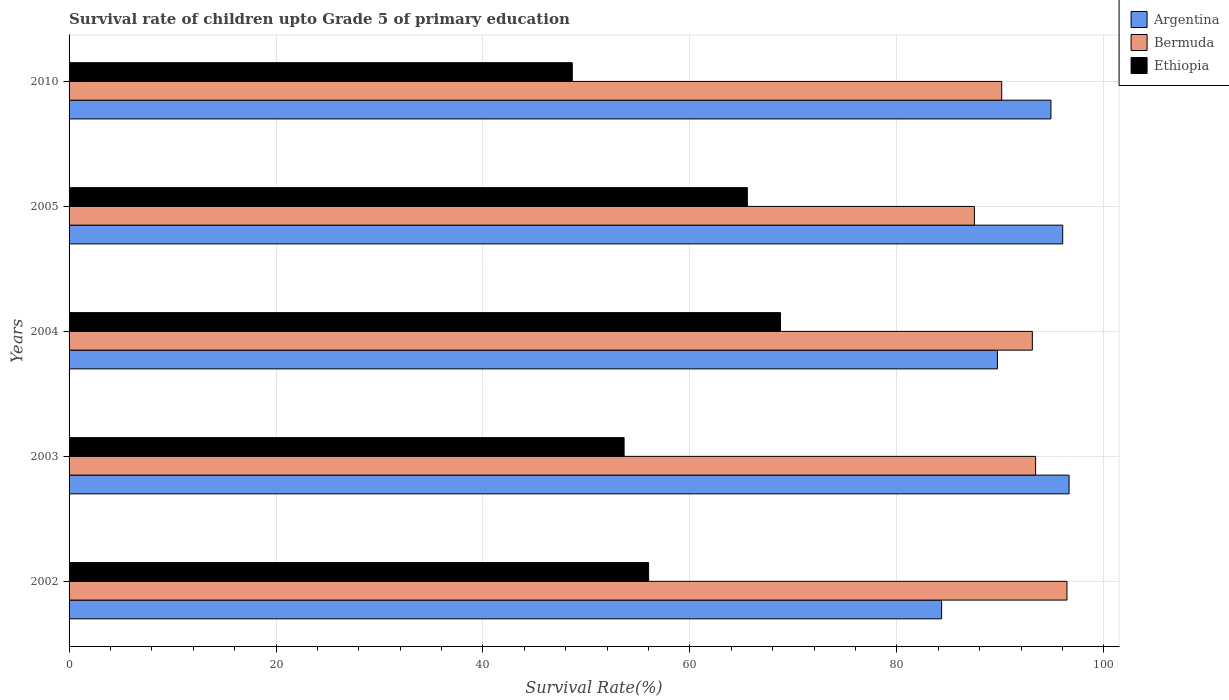How many different coloured bars are there?
Keep it short and to the point. 3. How many groups of bars are there?
Keep it short and to the point. 5. Are the number of bars on each tick of the Y-axis equal?
Your answer should be compact. Yes. How many bars are there on the 5th tick from the top?
Make the answer very short. 3. What is the survival rate of children in Argentina in 2004?
Make the answer very short. 89.72. Across all years, what is the maximum survival rate of children in Bermuda?
Offer a very short reply. 96.44. Across all years, what is the minimum survival rate of children in Ethiopia?
Your answer should be very brief. 48.63. In which year was the survival rate of children in Bermuda maximum?
Your response must be concise. 2002. What is the total survival rate of children in Ethiopia in the graph?
Your answer should be very brief. 292.58. What is the difference between the survival rate of children in Argentina in 2005 and that in 2010?
Provide a succinct answer. 1.14. What is the difference between the survival rate of children in Ethiopia in 2003 and the survival rate of children in Bermuda in 2002?
Your response must be concise. -42.8. What is the average survival rate of children in Ethiopia per year?
Your response must be concise. 58.52. In the year 2005, what is the difference between the survival rate of children in Ethiopia and survival rate of children in Bermuda?
Your response must be concise. -21.94. What is the ratio of the survival rate of children in Bermuda in 2003 to that in 2004?
Ensure brevity in your answer.  1. Is the survival rate of children in Ethiopia in 2002 less than that in 2004?
Make the answer very short. Yes. What is the difference between the highest and the second highest survival rate of children in Bermuda?
Provide a succinct answer. 3.03. What is the difference between the highest and the lowest survival rate of children in Bermuda?
Your answer should be very brief. 8.95. What does the 1st bar from the top in 2004 represents?
Your answer should be compact. Ethiopia. What does the 2nd bar from the bottom in 2010 represents?
Give a very brief answer. Bermuda. Is it the case that in every year, the sum of the survival rate of children in Argentina and survival rate of children in Bermuda is greater than the survival rate of children in Ethiopia?
Your answer should be compact. Yes. How many bars are there?
Your answer should be compact. 15. Are all the bars in the graph horizontal?
Keep it short and to the point. Yes. How many years are there in the graph?
Give a very brief answer. 5. Does the graph contain grids?
Offer a terse response. Yes. How are the legend labels stacked?
Provide a succinct answer. Vertical. What is the title of the graph?
Provide a short and direct response. Survival rate of children upto Grade 5 of primary education. Does "Lao PDR" appear as one of the legend labels in the graph?
Provide a succinct answer. No. What is the label or title of the X-axis?
Keep it short and to the point. Survival Rate(%). What is the Survival Rate(%) in Argentina in 2002?
Your response must be concise. 84.33. What is the Survival Rate(%) of Bermuda in 2002?
Provide a succinct answer. 96.44. What is the Survival Rate(%) of Ethiopia in 2002?
Provide a short and direct response. 56.01. What is the Survival Rate(%) in Argentina in 2003?
Your response must be concise. 96.64. What is the Survival Rate(%) in Bermuda in 2003?
Your response must be concise. 93.41. What is the Survival Rate(%) of Ethiopia in 2003?
Give a very brief answer. 53.64. What is the Survival Rate(%) in Argentina in 2004?
Offer a very short reply. 89.72. What is the Survival Rate(%) of Bermuda in 2004?
Your answer should be compact. 93.1. What is the Survival Rate(%) of Ethiopia in 2004?
Provide a succinct answer. 68.75. What is the Survival Rate(%) of Argentina in 2005?
Keep it short and to the point. 96.03. What is the Survival Rate(%) in Bermuda in 2005?
Your answer should be compact. 87.5. What is the Survival Rate(%) of Ethiopia in 2005?
Offer a very short reply. 65.55. What is the Survival Rate(%) of Argentina in 2010?
Give a very brief answer. 94.89. What is the Survival Rate(%) in Bermuda in 2010?
Make the answer very short. 90.13. What is the Survival Rate(%) of Ethiopia in 2010?
Provide a short and direct response. 48.63. Across all years, what is the maximum Survival Rate(%) of Argentina?
Give a very brief answer. 96.64. Across all years, what is the maximum Survival Rate(%) in Bermuda?
Offer a terse response. 96.44. Across all years, what is the maximum Survival Rate(%) of Ethiopia?
Keep it short and to the point. 68.75. Across all years, what is the minimum Survival Rate(%) in Argentina?
Provide a short and direct response. 84.33. Across all years, what is the minimum Survival Rate(%) in Bermuda?
Give a very brief answer. 87.5. Across all years, what is the minimum Survival Rate(%) in Ethiopia?
Offer a very short reply. 48.63. What is the total Survival Rate(%) in Argentina in the graph?
Provide a succinct answer. 461.61. What is the total Survival Rate(%) in Bermuda in the graph?
Keep it short and to the point. 460.58. What is the total Survival Rate(%) in Ethiopia in the graph?
Keep it short and to the point. 292.58. What is the difference between the Survival Rate(%) of Argentina in 2002 and that in 2003?
Your response must be concise. -12.32. What is the difference between the Survival Rate(%) in Bermuda in 2002 and that in 2003?
Keep it short and to the point. 3.03. What is the difference between the Survival Rate(%) in Ethiopia in 2002 and that in 2003?
Provide a succinct answer. 2.37. What is the difference between the Survival Rate(%) of Argentina in 2002 and that in 2004?
Your answer should be compact. -5.39. What is the difference between the Survival Rate(%) in Bermuda in 2002 and that in 2004?
Your answer should be compact. 3.35. What is the difference between the Survival Rate(%) of Ethiopia in 2002 and that in 2004?
Provide a succinct answer. -12.74. What is the difference between the Survival Rate(%) in Argentina in 2002 and that in 2005?
Provide a short and direct response. -11.7. What is the difference between the Survival Rate(%) in Bermuda in 2002 and that in 2005?
Ensure brevity in your answer.  8.95. What is the difference between the Survival Rate(%) in Ethiopia in 2002 and that in 2005?
Ensure brevity in your answer.  -9.54. What is the difference between the Survival Rate(%) of Argentina in 2002 and that in 2010?
Offer a terse response. -10.57. What is the difference between the Survival Rate(%) in Bermuda in 2002 and that in 2010?
Provide a short and direct response. 6.31. What is the difference between the Survival Rate(%) of Ethiopia in 2002 and that in 2010?
Offer a terse response. 7.38. What is the difference between the Survival Rate(%) of Argentina in 2003 and that in 2004?
Your response must be concise. 6.93. What is the difference between the Survival Rate(%) in Bermuda in 2003 and that in 2004?
Offer a terse response. 0.32. What is the difference between the Survival Rate(%) in Ethiopia in 2003 and that in 2004?
Your answer should be compact. -15.11. What is the difference between the Survival Rate(%) in Argentina in 2003 and that in 2005?
Ensure brevity in your answer.  0.62. What is the difference between the Survival Rate(%) of Bermuda in 2003 and that in 2005?
Give a very brief answer. 5.92. What is the difference between the Survival Rate(%) of Ethiopia in 2003 and that in 2005?
Offer a very short reply. -11.91. What is the difference between the Survival Rate(%) of Argentina in 2003 and that in 2010?
Ensure brevity in your answer.  1.75. What is the difference between the Survival Rate(%) of Bermuda in 2003 and that in 2010?
Offer a very short reply. 3.28. What is the difference between the Survival Rate(%) in Ethiopia in 2003 and that in 2010?
Offer a very short reply. 5.01. What is the difference between the Survival Rate(%) in Argentina in 2004 and that in 2005?
Your response must be concise. -6.31. What is the difference between the Survival Rate(%) in Bermuda in 2004 and that in 2005?
Keep it short and to the point. 5.6. What is the difference between the Survival Rate(%) of Ethiopia in 2004 and that in 2005?
Make the answer very short. 3.2. What is the difference between the Survival Rate(%) in Argentina in 2004 and that in 2010?
Offer a very short reply. -5.17. What is the difference between the Survival Rate(%) in Bermuda in 2004 and that in 2010?
Make the answer very short. 2.96. What is the difference between the Survival Rate(%) of Ethiopia in 2004 and that in 2010?
Ensure brevity in your answer.  20.12. What is the difference between the Survival Rate(%) of Argentina in 2005 and that in 2010?
Give a very brief answer. 1.14. What is the difference between the Survival Rate(%) of Bermuda in 2005 and that in 2010?
Offer a terse response. -2.64. What is the difference between the Survival Rate(%) in Ethiopia in 2005 and that in 2010?
Your response must be concise. 16.92. What is the difference between the Survival Rate(%) in Argentina in 2002 and the Survival Rate(%) in Bermuda in 2003?
Your answer should be compact. -9.08. What is the difference between the Survival Rate(%) in Argentina in 2002 and the Survival Rate(%) in Ethiopia in 2003?
Offer a very short reply. 30.69. What is the difference between the Survival Rate(%) of Bermuda in 2002 and the Survival Rate(%) of Ethiopia in 2003?
Offer a very short reply. 42.8. What is the difference between the Survival Rate(%) of Argentina in 2002 and the Survival Rate(%) of Bermuda in 2004?
Offer a very short reply. -8.77. What is the difference between the Survival Rate(%) in Argentina in 2002 and the Survival Rate(%) in Ethiopia in 2004?
Keep it short and to the point. 15.58. What is the difference between the Survival Rate(%) of Bermuda in 2002 and the Survival Rate(%) of Ethiopia in 2004?
Your answer should be very brief. 27.69. What is the difference between the Survival Rate(%) in Argentina in 2002 and the Survival Rate(%) in Bermuda in 2005?
Keep it short and to the point. -3.17. What is the difference between the Survival Rate(%) of Argentina in 2002 and the Survival Rate(%) of Ethiopia in 2005?
Give a very brief answer. 18.77. What is the difference between the Survival Rate(%) in Bermuda in 2002 and the Survival Rate(%) in Ethiopia in 2005?
Your answer should be compact. 30.89. What is the difference between the Survival Rate(%) in Argentina in 2002 and the Survival Rate(%) in Bermuda in 2010?
Offer a very short reply. -5.81. What is the difference between the Survival Rate(%) in Argentina in 2002 and the Survival Rate(%) in Ethiopia in 2010?
Make the answer very short. 35.7. What is the difference between the Survival Rate(%) of Bermuda in 2002 and the Survival Rate(%) of Ethiopia in 2010?
Make the answer very short. 47.81. What is the difference between the Survival Rate(%) of Argentina in 2003 and the Survival Rate(%) of Bermuda in 2004?
Your answer should be compact. 3.55. What is the difference between the Survival Rate(%) in Argentina in 2003 and the Survival Rate(%) in Ethiopia in 2004?
Offer a terse response. 27.89. What is the difference between the Survival Rate(%) of Bermuda in 2003 and the Survival Rate(%) of Ethiopia in 2004?
Provide a short and direct response. 24.66. What is the difference between the Survival Rate(%) of Argentina in 2003 and the Survival Rate(%) of Bermuda in 2005?
Your answer should be compact. 9.15. What is the difference between the Survival Rate(%) in Argentina in 2003 and the Survival Rate(%) in Ethiopia in 2005?
Provide a short and direct response. 31.09. What is the difference between the Survival Rate(%) of Bermuda in 2003 and the Survival Rate(%) of Ethiopia in 2005?
Give a very brief answer. 27.86. What is the difference between the Survival Rate(%) of Argentina in 2003 and the Survival Rate(%) of Bermuda in 2010?
Your answer should be very brief. 6.51. What is the difference between the Survival Rate(%) of Argentina in 2003 and the Survival Rate(%) of Ethiopia in 2010?
Offer a very short reply. 48.01. What is the difference between the Survival Rate(%) in Bermuda in 2003 and the Survival Rate(%) in Ethiopia in 2010?
Provide a succinct answer. 44.78. What is the difference between the Survival Rate(%) in Argentina in 2004 and the Survival Rate(%) in Bermuda in 2005?
Your answer should be compact. 2.22. What is the difference between the Survival Rate(%) in Argentina in 2004 and the Survival Rate(%) in Ethiopia in 2005?
Ensure brevity in your answer.  24.17. What is the difference between the Survival Rate(%) of Bermuda in 2004 and the Survival Rate(%) of Ethiopia in 2005?
Offer a very short reply. 27.54. What is the difference between the Survival Rate(%) of Argentina in 2004 and the Survival Rate(%) of Bermuda in 2010?
Your answer should be compact. -0.41. What is the difference between the Survival Rate(%) of Argentina in 2004 and the Survival Rate(%) of Ethiopia in 2010?
Provide a short and direct response. 41.09. What is the difference between the Survival Rate(%) in Bermuda in 2004 and the Survival Rate(%) in Ethiopia in 2010?
Ensure brevity in your answer.  44.46. What is the difference between the Survival Rate(%) of Argentina in 2005 and the Survival Rate(%) of Bermuda in 2010?
Provide a short and direct response. 5.9. What is the difference between the Survival Rate(%) of Argentina in 2005 and the Survival Rate(%) of Ethiopia in 2010?
Offer a very short reply. 47.4. What is the difference between the Survival Rate(%) in Bermuda in 2005 and the Survival Rate(%) in Ethiopia in 2010?
Your answer should be very brief. 38.86. What is the average Survival Rate(%) of Argentina per year?
Offer a terse response. 92.32. What is the average Survival Rate(%) of Bermuda per year?
Give a very brief answer. 92.12. What is the average Survival Rate(%) of Ethiopia per year?
Offer a very short reply. 58.52. In the year 2002, what is the difference between the Survival Rate(%) in Argentina and Survival Rate(%) in Bermuda?
Keep it short and to the point. -12.12. In the year 2002, what is the difference between the Survival Rate(%) of Argentina and Survival Rate(%) of Ethiopia?
Provide a short and direct response. 28.32. In the year 2002, what is the difference between the Survival Rate(%) in Bermuda and Survival Rate(%) in Ethiopia?
Keep it short and to the point. 40.43. In the year 2003, what is the difference between the Survival Rate(%) in Argentina and Survival Rate(%) in Bermuda?
Your response must be concise. 3.23. In the year 2003, what is the difference between the Survival Rate(%) in Argentina and Survival Rate(%) in Ethiopia?
Provide a succinct answer. 43. In the year 2003, what is the difference between the Survival Rate(%) of Bermuda and Survival Rate(%) of Ethiopia?
Give a very brief answer. 39.77. In the year 2004, what is the difference between the Survival Rate(%) in Argentina and Survival Rate(%) in Bermuda?
Your response must be concise. -3.38. In the year 2004, what is the difference between the Survival Rate(%) of Argentina and Survival Rate(%) of Ethiopia?
Provide a succinct answer. 20.97. In the year 2004, what is the difference between the Survival Rate(%) of Bermuda and Survival Rate(%) of Ethiopia?
Ensure brevity in your answer.  24.34. In the year 2005, what is the difference between the Survival Rate(%) of Argentina and Survival Rate(%) of Bermuda?
Offer a very short reply. 8.53. In the year 2005, what is the difference between the Survival Rate(%) of Argentina and Survival Rate(%) of Ethiopia?
Offer a terse response. 30.48. In the year 2005, what is the difference between the Survival Rate(%) in Bermuda and Survival Rate(%) in Ethiopia?
Offer a terse response. 21.94. In the year 2010, what is the difference between the Survival Rate(%) in Argentina and Survival Rate(%) in Bermuda?
Offer a terse response. 4.76. In the year 2010, what is the difference between the Survival Rate(%) of Argentina and Survival Rate(%) of Ethiopia?
Keep it short and to the point. 46.26. In the year 2010, what is the difference between the Survival Rate(%) in Bermuda and Survival Rate(%) in Ethiopia?
Offer a terse response. 41.5. What is the ratio of the Survival Rate(%) of Argentina in 2002 to that in 2003?
Your response must be concise. 0.87. What is the ratio of the Survival Rate(%) in Bermuda in 2002 to that in 2003?
Give a very brief answer. 1.03. What is the ratio of the Survival Rate(%) of Ethiopia in 2002 to that in 2003?
Your answer should be very brief. 1.04. What is the ratio of the Survival Rate(%) in Argentina in 2002 to that in 2004?
Your answer should be compact. 0.94. What is the ratio of the Survival Rate(%) of Bermuda in 2002 to that in 2004?
Your answer should be compact. 1.04. What is the ratio of the Survival Rate(%) in Ethiopia in 2002 to that in 2004?
Keep it short and to the point. 0.81. What is the ratio of the Survival Rate(%) of Argentina in 2002 to that in 2005?
Give a very brief answer. 0.88. What is the ratio of the Survival Rate(%) of Bermuda in 2002 to that in 2005?
Your answer should be very brief. 1.1. What is the ratio of the Survival Rate(%) of Ethiopia in 2002 to that in 2005?
Provide a succinct answer. 0.85. What is the ratio of the Survival Rate(%) of Argentina in 2002 to that in 2010?
Offer a terse response. 0.89. What is the ratio of the Survival Rate(%) of Bermuda in 2002 to that in 2010?
Your response must be concise. 1.07. What is the ratio of the Survival Rate(%) of Ethiopia in 2002 to that in 2010?
Offer a very short reply. 1.15. What is the ratio of the Survival Rate(%) in Argentina in 2003 to that in 2004?
Make the answer very short. 1.08. What is the ratio of the Survival Rate(%) of Ethiopia in 2003 to that in 2004?
Offer a terse response. 0.78. What is the ratio of the Survival Rate(%) of Argentina in 2003 to that in 2005?
Your answer should be compact. 1.01. What is the ratio of the Survival Rate(%) in Bermuda in 2003 to that in 2005?
Provide a short and direct response. 1.07. What is the ratio of the Survival Rate(%) of Ethiopia in 2003 to that in 2005?
Offer a terse response. 0.82. What is the ratio of the Survival Rate(%) in Argentina in 2003 to that in 2010?
Your answer should be very brief. 1.02. What is the ratio of the Survival Rate(%) in Bermuda in 2003 to that in 2010?
Provide a short and direct response. 1.04. What is the ratio of the Survival Rate(%) in Ethiopia in 2003 to that in 2010?
Make the answer very short. 1.1. What is the ratio of the Survival Rate(%) of Argentina in 2004 to that in 2005?
Provide a succinct answer. 0.93. What is the ratio of the Survival Rate(%) of Bermuda in 2004 to that in 2005?
Provide a short and direct response. 1.06. What is the ratio of the Survival Rate(%) of Ethiopia in 2004 to that in 2005?
Provide a succinct answer. 1.05. What is the ratio of the Survival Rate(%) of Argentina in 2004 to that in 2010?
Your answer should be compact. 0.95. What is the ratio of the Survival Rate(%) of Bermuda in 2004 to that in 2010?
Provide a succinct answer. 1.03. What is the ratio of the Survival Rate(%) in Ethiopia in 2004 to that in 2010?
Offer a very short reply. 1.41. What is the ratio of the Survival Rate(%) in Bermuda in 2005 to that in 2010?
Keep it short and to the point. 0.97. What is the ratio of the Survival Rate(%) in Ethiopia in 2005 to that in 2010?
Offer a terse response. 1.35. What is the difference between the highest and the second highest Survival Rate(%) of Argentina?
Provide a succinct answer. 0.62. What is the difference between the highest and the second highest Survival Rate(%) in Bermuda?
Your answer should be compact. 3.03. What is the difference between the highest and the second highest Survival Rate(%) of Ethiopia?
Make the answer very short. 3.2. What is the difference between the highest and the lowest Survival Rate(%) of Argentina?
Your answer should be very brief. 12.32. What is the difference between the highest and the lowest Survival Rate(%) in Bermuda?
Your answer should be compact. 8.95. What is the difference between the highest and the lowest Survival Rate(%) in Ethiopia?
Make the answer very short. 20.12. 